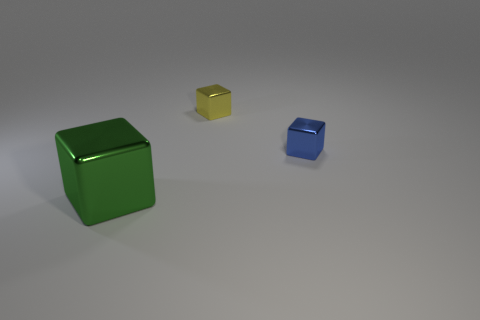Does the small shiny cube in front of the yellow block have the same color as the large cube? no 